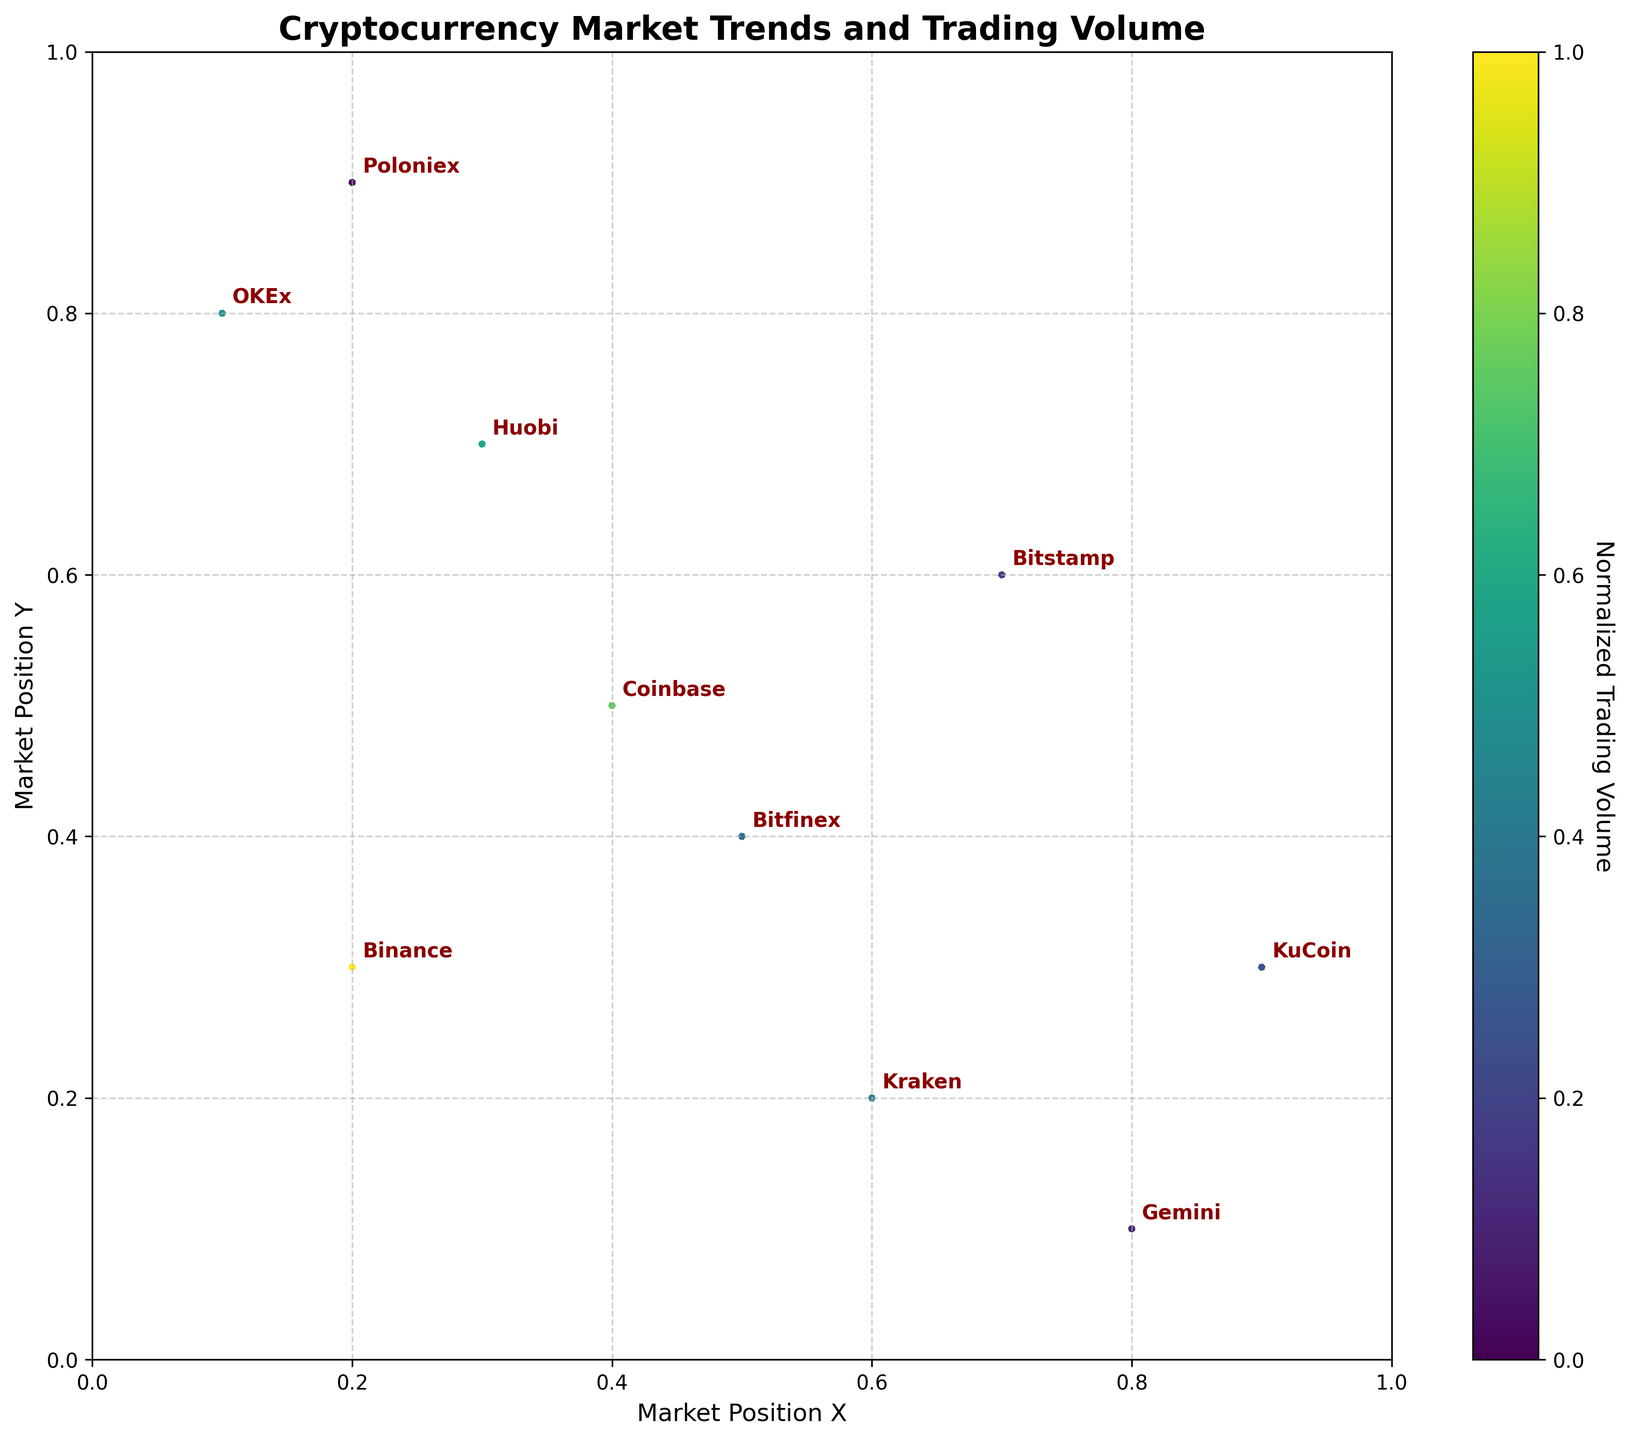what's the most notable element of this figure? The title of the figure, "Cryptocurrency Market Trends and Trading Volume," clearly indicates the main focus area. This title is visually prominent and gives context to the rest of the data shown in the figure.
Answer: The title How many different exchanges are represented in the plot? Count the number of unique exchange names labeled on the plot. Each unique label corresponds to one exchange.
Answer: 10 Which exchange has the highest trading volume? By observing the color intensity in the figure (linked to normalized trading intensity), the exchange with the highest volume will have the most intense color. Since the volume was normalized for color intensity, identify the exchange corresponding to the highest color intensity.
Answer: Binance What is the movement trend for the Binance exchange? The quiver (arrow) direction for Binance shows the movement trend. For Binance, observe the starting point at (0.2, 0.3) and the direction determined by the u (0.05) and v (-0.02) vectors.
Answer: Moving slightly right and down Which exchange shows a downward and rightward movement? Identify the arrow starting points and vectors. The exchange with both downward (negative v) and rightward (positive u) vector components fits this description. OKEx's arrow moves down (v=-0.04) and right (u=0.03).
Answer: OKEx Compare the trading volume between Huobi and Bitfinex. Which one is higher? Observe the color intensity of the arrows for both exchanges. Huobi's and Bitfinex's colors represent their normalized volumes. Huobi has a higher color intensity compared to Bitfinex.
Answer: Huobi Which exchange has the smallest trading volume? Identify the exchange with the least intense color in the normalized volume scale. In the plot, Poloniex exhibits the least intense color, indicating the smallest trading volume.
Answer: Poloniex What is the average x-position of Binance, Kraken, and OKEx? Add the x-positions of Binance (0.2), Kraken (0.6), and OKEx (0.1), then divide the sum by the number of exchanges (3). Calculation: (0.2 + 0.6 + 0.1) / 3 = 0.3
Answer: 0.3 Which exchange moves in the most upward direction? Check the vectors (u, v) of each exchange and find the one with the highest positive v-value. Gemini with v=0.05 shows the highest upward movement.
Answer: Gemini 